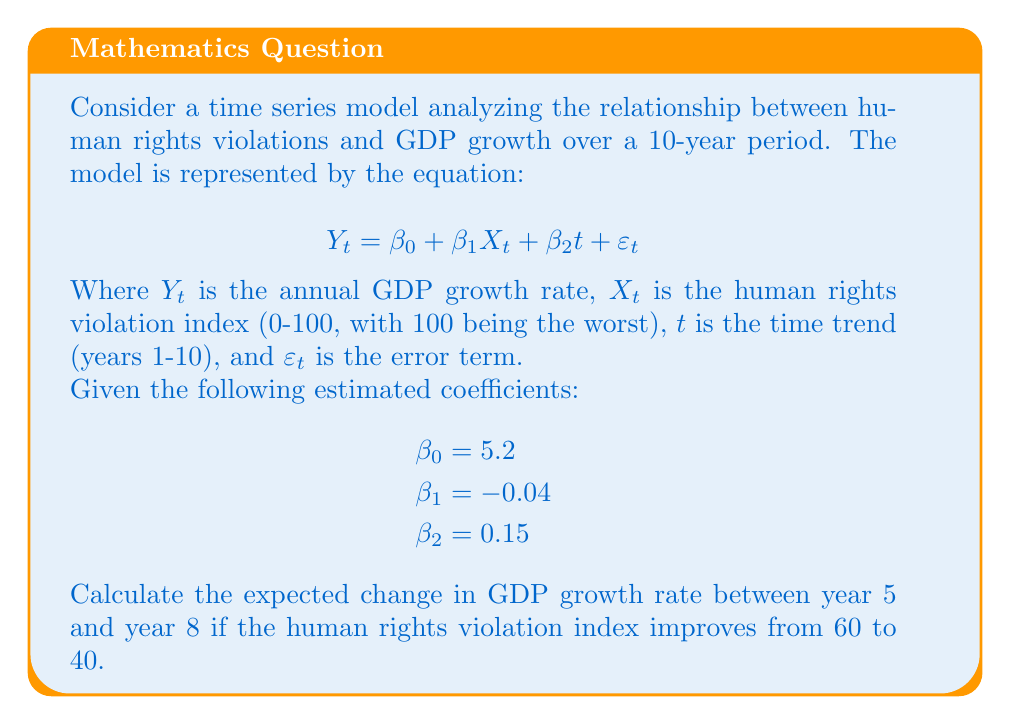What is the answer to this math problem? To solve this problem, we need to follow these steps:

1. Calculate the expected GDP growth rate for year 5 with the initial human rights violation index.
2. Calculate the expected GDP growth rate for year 8 with the improved human rights violation index.
3. Find the difference between these two values.

Step 1: Calculate GDP growth rate for year 5 (t = 5, X = 60)
$$Y_5 = \beta_0 + \beta_1X_5 + \beta_2t$$
$$Y_5 = 5.2 + (-0.04 \times 60) + (0.15 \times 5)$$
$$Y_5 = 5.2 - 2.4 + 0.75 = 3.55\%$$

Step 2: Calculate GDP growth rate for year 8 (t = 8, X = 40)
$$Y_8 = \beta_0 + \beta_1X_8 + \beta_2t$$
$$Y_8 = 5.2 + (-0.04 \times 40) + (0.15 \times 8)$$
$$Y_8 = 5.2 - 1.6 + 1.2 = 4.8\%$$

Step 3: Calculate the difference
Change in GDP growth rate = $Y_8 - Y_5 = 4.8\% - 3.55\% = 1.25\%$

The positive change indicates an increase in the GDP growth rate, which is expected due to the improvement in the human rights situation and the positive time trend.
Answer: The expected change in GDP growth rate between year 5 and year 8, given the improvement in the human rights violation index, is an increase of 1.25 percentage points. 